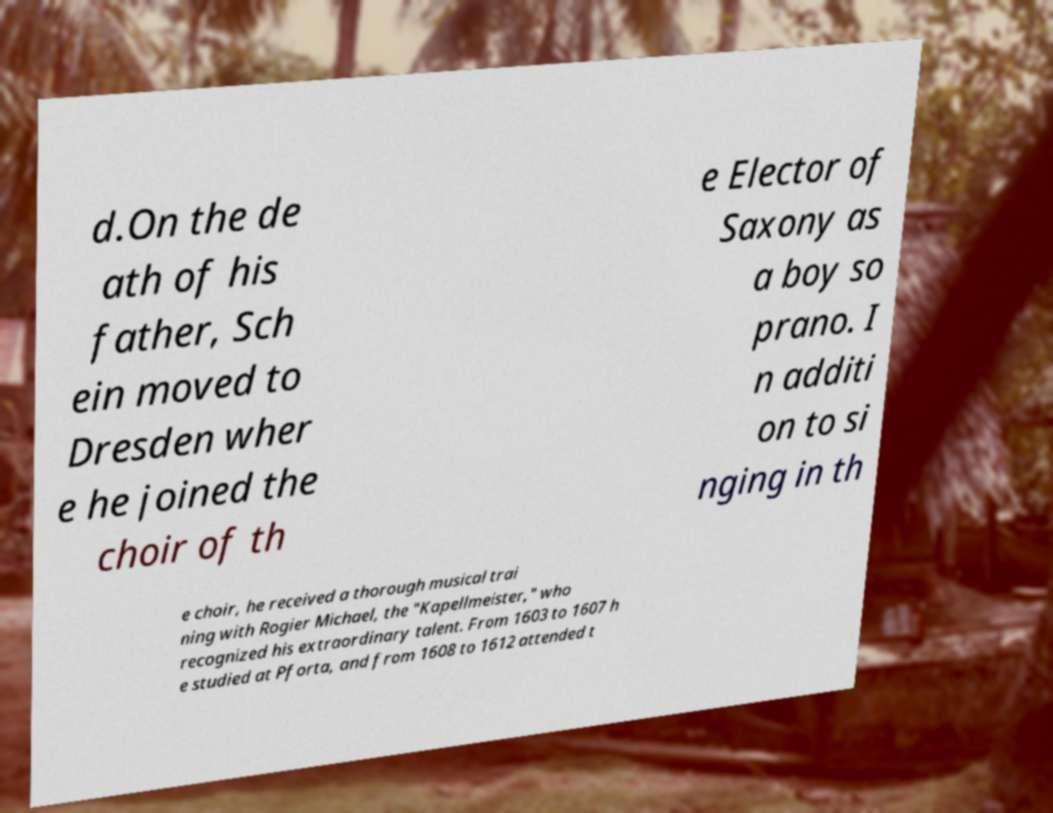Could you extract and type out the text from this image? d.On the de ath of his father, Sch ein moved to Dresden wher e he joined the choir of th e Elector of Saxony as a boy so prano. I n additi on to si nging in th e choir, he received a thorough musical trai ning with Rogier Michael, the "Kapellmeister," who recognized his extraordinary talent. From 1603 to 1607 h e studied at Pforta, and from 1608 to 1612 attended t 